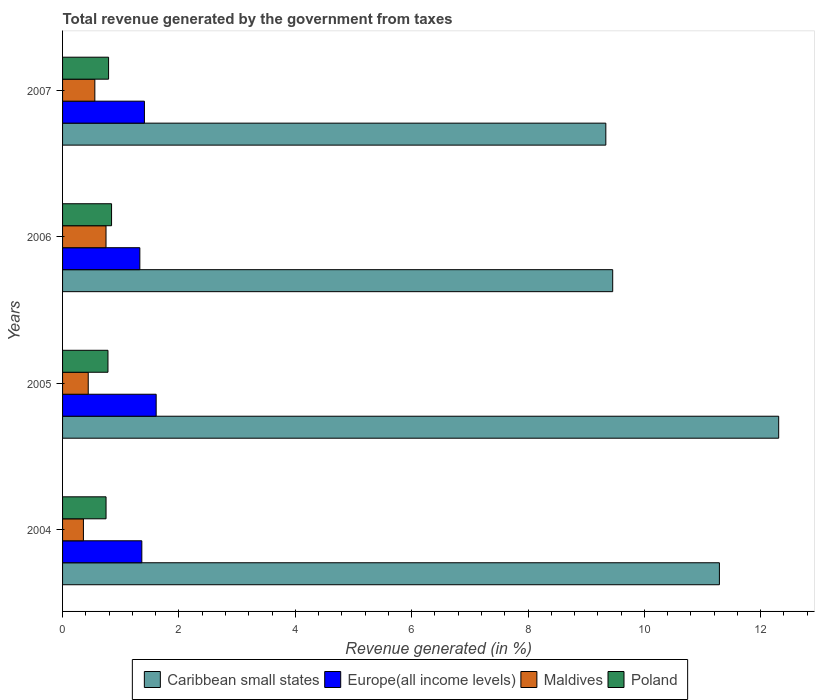How many different coloured bars are there?
Provide a short and direct response. 4. How many groups of bars are there?
Offer a very short reply. 4. Are the number of bars per tick equal to the number of legend labels?
Offer a very short reply. Yes. Are the number of bars on each tick of the Y-axis equal?
Ensure brevity in your answer.  Yes. How many bars are there on the 4th tick from the bottom?
Provide a succinct answer. 4. What is the label of the 4th group of bars from the top?
Offer a terse response. 2004. What is the total revenue generated in Europe(all income levels) in 2005?
Your response must be concise. 1.61. Across all years, what is the maximum total revenue generated in Poland?
Provide a short and direct response. 0.84. Across all years, what is the minimum total revenue generated in Maldives?
Offer a very short reply. 0.36. In which year was the total revenue generated in Maldives minimum?
Ensure brevity in your answer.  2004. What is the total total revenue generated in Maldives in the graph?
Your answer should be very brief. 2.1. What is the difference between the total revenue generated in Caribbean small states in 2004 and that in 2006?
Make the answer very short. 1.83. What is the difference between the total revenue generated in Poland in 2004 and the total revenue generated in Caribbean small states in 2006?
Make the answer very short. -8.71. What is the average total revenue generated in Maldives per year?
Make the answer very short. 0.53. In the year 2005, what is the difference between the total revenue generated in Poland and total revenue generated in Caribbean small states?
Offer a terse response. -11.53. In how many years, is the total revenue generated in Europe(all income levels) greater than 6.4 %?
Your answer should be compact. 0. What is the ratio of the total revenue generated in Poland in 2004 to that in 2007?
Provide a succinct answer. 0.94. Is the difference between the total revenue generated in Poland in 2005 and 2006 greater than the difference between the total revenue generated in Caribbean small states in 2005 and 2006?
Your answer should be very brief. No. What is the difference between the highest and the second highest total revenue generated in Poland?
Provide a short and direct response. 0.05. What is the difference between the highest and the lowest total revenue generated in Poland?
Your answer should be very brief. 0.09. In how many years, is the total revenue generated in Europe(all income levels) greater than the average total revenue generated in Europe(all income levels) taken over all years?
Your answer should be compact. 1. What does the 2nd bar from the top in 2005 represents?
Your response must be concise. Maldives. What does the 3rd bar from the bottom in 2005 represents?
Your response must be concise. Maldives. How many bars are there?
Offer a terse response. 16. How many years are there in the graph?
Offer a terse response. 4. What is the difference between two consecutive major ticks on the X-axis?
Your response must be concise. 2. Are the values on the major ticks of X-axis written in scientific E-notation?
Ensure brevity in your answer.  No. Does the graph contain any zero values?
Give a very brief answer. No. Does the graph contain grids?
Provide a succinct answer. No. Where does the legend appear in the graph?
Ensure brevity in your answer.  Bottom center. What is the title of the graph?
Your answer should be very brief. Total revenue generated by the government from taxes. Does "Morocco" appear as one of the legend labels in the graph?
Offer a terse response. No. What is the label or title of the X-axis?
Offer a very short reply. Revenue generated (in %). What is the Revenue generated (in %) of Caribbean small states in 2004?
Offer a very short reply. 11.29. What is the Revenue generated (in %) of Europe(all income levels) in 2004?
Give a very brief answer. 1.36. What is the Revenue generated (in %) in Maldives in 2004?
Your response must be concise. 0.36. What is the Revenue generated (in %) of Poland in 2004?
Your answer should be compact. 0.75. What is the Revenue generated (in %) of Caribbean small states in 2005?
Make the answer very short. 12.31. What is the Revenue generated (in %) of Europe(all income levels) in 2005?
Your response must be concise. 1.61. What is the Revenue generated (in %) of Maldives in 2005?
Your answer should be compact. 0.44. What is the Revenue generated (in %) in Poland in 2005?
Your response must be concise. 0.78. What is the Revenue generated (in %) in Caribbean small states in 2006?
Ensure brevity in your answer.  9.46. What is the Revenue generated (in %) in Europe(all income levels) in 2006?
Your response must be concise. 1.33. What is the Revenue generated (in %) of Maldives in 2006?
Provide a succinct answer. 0.75. What is the Revenue generated (in %) of Poland in 2006?
Offer a terse response. 0.84. What is the Revenue generated (in %) in Caribbean small states in 2007?
Keep it short and to the point. 9.34. What is the Revenue generated (in %) in Europe(all income levels) in 2007?
Offer a very short reply. 1.41. What is the Revenue generated (in %) in Maldives in 2007?
Your answer should be very brief. 0.55. What is the Revenue generated (in %) of Poland in 2007?
Offer a very short reply. 0.79. Across all years, what is the maximum Revenue generated (in %) in Caribbean small states?
Ensure brevity in your answer.  12.31. Across all years, what is the maximum Revenue generated (in %) of Europe(all income levels)?
Ensure brevity in your answer.  1.61. Across all years, what is the maximum Revenue generated (in %) of Maldives?
Provide a short and direct response. 0.75. Across all years, what is the maximum Revenue generated (in %) of Poland?
Provide a short and direct response. 0.84. Across all years, what is the minimum Revenue generated (in %) of Caribbean small states?
Provide a short and direct response. 9.34. Across all years, what is the minimum Revenue generated (in %) in Europe(all income levels)?
Ensure brevity in your answer.  1.33. Across all years, what is the minimum Revenue generated (in %) in Maldives?
Your response must be concise. 0.36. Across all years, what is the minimum Revenue generated (in %) of Poland?
Provide a short and direct response. 0.75. What is the total Revenue generated (in %) of Caribbean small states in the graph?
Give a very brief answer. 42.39. What is the total Revenue generated (in %) of Europe(all income levels) in the graph?
Offer a very short reply. 5.71. What is the total Revenue generated (in %) in Maldives in the graph?
Your answer should be very brief. 2.1. What is the total Revenue generated (in %) in Poland in the graph?
Provide a succinct answer. 3.16. What is the difference between the Revenue generated (in %) in Caribbean small states in 2004 and that in 2005?
Ensure brevity in your answer.  -1.02. What is the difference between the Revenue generated (in %) in Europe(all income levels) in 2004 and that in 2005?
Provide a succinct answer. -0.25. What is the difference between the Revenue generated (in %) of Maldives in 2004 and that in 2005?
Your response must be concise. -0.08. What is the difference between the Revenue generated (in %) in Poland in 2004 and that in 2005?
Offer a very short reply. -0.03. What is the difference between the Revenue generated (in %) of Caribbean small states in 2004 and that in 2006?
Offer a terse response. 1.83. What is the difference between the Revenue generated (in %) of Europe(all income levels) in 2004 and that in 2006?
Keep it short and to the point. 0.03. What is the difference between the Revenue generated (in %) of Maldives in 2004 and that in 2006?
Ensure brevity in your answer.  -0.39. What is the difference between the Revenue generated (in %) of Poland in 2004 and that in 2006?
Make the answer very short. -0.09. What is the difference between the Revenue generated (in %) in Caribbean small states in 2004 and that in 2007?
Give a very brief answer. 1.95. What is the difference between the Revenue generated (in %) in Europe(all income levels) in 2004 and that in 2007?
Offer a very short reply. -0.04. What is the difference between the Revenue generated (in %) in Maldives in 2004 and that in 2007?
Ensure brevity in your answer.  -0.2. What is the difference between the Revenue generated (in %) in Poland in 2004 and that in 2007?
Your answer should be very brief. -0.04. What is the difference between the Revenue generated (in %) of Caribbean small states in 2005 and that in 2006?
Ensure brevity in your answer.  2.85. What is the difference between the Revenue generated (in %) in Europe(all income levels) in 2005 and that in 2006?
Provide a succinct answer. 0.28. What is the difference between the Revenue generated (in %) in Maldives in 2005 and that in 2006?
Provide a short and direct response. -0.31. What is the difference between the Revenue generated (in %) in Poland in 2005 and that in 2006?
Keep it short and to the point. -0.06. What is the difference between the Revenue generated (in %) in Caribbean small states in 2005 and that in 2007?
Keep it short and to the point. 2.97. What is the difference between the Revenue generated (in %) in Europe(all income levels) in 2005 and that in 2007?
Give a very brief answer. 0.2. What is the difference between the Revenue generated (in %) in Maldives in 2005 and that in 2007?
Offer a terse response. -0.11. What is the difference between the Revenue generated (in %) of Poland in 2005 and that in 2007?
Provide a succinct answer. -0.01. What is the difference between the Revenue generated (in %) of Caribbean small states in 2006 and that in 2007?
Give a very brief answer. 0.12. What is the difference between the Revenue generated (in %) in Europe(all income levels) in 2006 and that in 2007?
Make the answer very short. -0.08. What is the difference between the Revenue generated (in %) in Maldives in 2006 and that in 2007?
Provide a short and direct response. 0.19. What is the difference between the Revenue generated (in %) in Poland in 2006 and that in 2007?
Offer a terse response. 0.05. What is the difference between the Revenue generated (in %) in Caribbean small states in 2004 and the Revenue generated (in %) in Europe(all income levels) in 2005?
Offer a terse response. 9.68. What is the difference between the Revenue generated (in %) of Caribbean small states in 2004 and the Revenue generated (in %) of Maldives in 2005?
Make the answer very short. 10.85. What is the difference between the Revenue generated (in %) of Caribbean small states in 2004 and the Revenue generated (in %) of Poland in 2005?
Keep it short and to the point. 10.51. What is the difference between the Revenue generated (in %) in Europe(all income levels) in 2004 and the Revenue generated (in %) in Maldives in 2005?
Ensure brevity in your answer.  0.92. What is the difference between the Revenue generated (in %) in Europe(all income levels) in 2004 and the Revenue generated (in %) in Poland in 2005?
Keep it short and to the point. 0.58. What is the difference between the Revenue generated (in %) of Maldives in 2004 and the Revenue generated (in %) of Poland in 2005?
Offer a terse response. -0.42. What is the difference between the Revenue generated (in %) in Caribbean small states in 2004 and the Revenue generated (in %) in Europe(all income levels) in 2006?
Your response must be concise. 9.96. What is the difference between the Revenue generated (in %) of Caribbean small states in 2004 and the Revenue generated (in %) of Maldives in 2006?
Keep it short and to the point. 10.54. What is the difference between the Revenue generated (in %) in Caribbean small states in 2004 and the Revenue generated (in %) in Poland in 2006?
Provide a short and direct response. 10.45. What is the difference between the Revenue generated (in %) in Europe(all income levels) in 2004 and the Revenue generated (in %) in Maldives in 2006?
Your answer should be very brief. 0.62. What is the difference between the Revenue generated (in %) of Europe(all income levels) in 2004 and the Revenue generated (in %) of Poland in 2006?
Your answer should be very brief. 0.52. What is the difference between the Revenue generated (in %) in Maldives in 2004 and the Revenue generated (in %) in Poland in 2006?
Ensure brevity in your answer.  -0.48. What is the difference between the Revenue generated (in %) of Caribbean small states in 2004 and the Revenue generated (in %) of Europe(all income levels) in 2007?
Offer a terse response. 9.88. What is the difference between the Revenue generated (in %) of Caribbean small states in 2004 and the Revenue generated (in %) of Maldives in 2007?
Your answer should be very brief. 10.74. What is the difference between the Revenue generated (in %) in Caribbean small states in 2004 and the Revenue generated (in %) in Poland in 2007?
Your answer should be compact. 10.5. What is the difference between the Revenue generated (in %) in Europe(all income levels) in 2004 and the Revenue generated (in %) in Maldives in 2007?
Your answer should be very brief. 0.81. What is the difference between the Revenue generated (in %) of Maldives in 2004 and the Revenue generated (in %) of Poland in 2007?
Provide a succinct answer. -0.43. What is the difference between the Revenue generated (in %) of Caribbean small states in 2005 and the Revenue generated (in %) of Europe(all income levels) in 2006?
Offer a terse response. 10.98. What is the difference between the Revenue generated (in %) of Caribbean small states in 2005 and the Revenue generated (in %) of Maldives in 2006?
Offer a terse response. 11.56. What is the difference between the Revenue generated (in %) in Caribbean small states in 2005 and the Revenue generated (in %) in Poland in 2006?
Offer a very short reply. 11.47. What is the difference between the Revenue generated (in %) of Europe(all income levels) in 2005 and the Revenue generated (in %) of Maldives in 2006?
Your answer should be compact. 0.86. What is the difference between the Revenue generated (in %) in Europe(all income levels) in 2005 and the Revenue generated (in %) in Poland in 2006?
Your response must be concise. 0.77. What is the difference between the Revenue generated (in %) in Maldives in 2005 and the Revenue generated (in %) in Poland in 2006?
Offer a terse response. -0.4. What is the difference between the Revenue generated (in %) of Caribbean small states in 2005 and the Revenue generated (in %) of Europe(all income levels) in 2007?
Keep it short and to the point. 10.9. What is the difference between the Revenue generated (in %) in Caribbean small states in 2005 and the Revenue generated (in %) in Maldives in 2007?
Provide a succinct answer. 11.75. What is the difference between the Revenue generated (in %) in Caribbean small states in 2005 and the Revenue generated (in %) in Poland in 2007?
Provide a succinct answer. 11.52. What is the difference between the Revenue generated (in %) in Europe(all income levels) in 2005 and the Revenue generated (in %) in Maldives in 2007?
Offer a very short reply. 1.05. What is the difference between the Revenue generated (in %) of Europe(all income levels) in 2005 and the Revenue generated (in %) of Poland in 2007?
Give a very brief answer. 0.82. What is the difference between the Revenue generated (in %) in Maldives in 2005 and the Revenue generated (in %) in Poland in 2007?
Offer a terse response. -0.35. What is the difference between the Revenue generated (in %) of Caribbean small states in 2006 and the Revenue generated (in %) of Europe(all income levels) in 2007?
Your answer should be very brief. 8.05. What is the difference between the Revenue generated (in %) of Caribbean small states in 2006 and the Revenue generated (in %) of Maldives in 2007?
Provide a short and direct response. 8.9. What is the difference between the Revenue generated (in %) in Caribbean small states in 2006 and the Revenue generated (in %) in Poland in 2007?
Your response must be concise. 8.66. What is the difference between the Revenue generated (in %) of Europe(all income levels) in 2006 and the Revenue generated (in %) of Maldives in 2007?
Your response must be concise. 0.77. What is the difference between the Revenue generated (in %) of Europe(all income levels) in 2006 and the Revenue generated (in %) of Poland in 2007?
Provide a succinct answer. 0.54. What is the difference between the Revenue generated (in %) in Maldives in 2006 and the Revenue generated (in %) in Poland in 2007?
Your answer should be very brief. -0.04. What is the average Revenue generated (in %) in Caribbean small states per year?
Give a very brief answer. 10.6. What is the average Revenue generated (in %) in Europe(all income levels) per year?
Offer a very short reply. 1.43. What is the average Revenue generated (in %) in Maldives per year?
Your response must be concise. 0.53. What is the average Revenue generated (in %) in Poland per year?
Provide a succinct answer. 0.79. In the year 2004, what is the difference between the Revenue generated (in %) in Caribbean small states and Revenue generated (in %) in Europe(all income levels)?
Your answer should be compact. 9.93. In the year 2004, what is the difference between the Revenue generated (in %) in Caribbean small states and Revenue generated (in %) in Maldives?
Offer a terse response. 10.93. In the year 2004, what is the difference between the Revenue generated (in %) in Caribbean small states and Revenue generated (in %) in Poland?
Keep it short and to the point. 10.54. In the year 2004, what is the difference between the Revenue generated (in %) in Europe(all income levels) and Revenue generated (in %) in Poland?
Ensure brevity in your answer.  0.61. In the year 2004, what is the difference between the Revenue generated (in %) in Maldives and Revenue generated (in %) in Poland?
Give a very brief answer. -0.39. In the year 2005, what is the difference between the Revenue generated (in %) of Caribbean small states and Revenue generated (in %) of Maldives?
Offer a very short reply. 11.87. In the year 2005, what is the difference between the Revenue generated (in %) in Caribbean small states and Revenue generated (in %) in Poland?
Offer a terse response. 11.53. In the year 2005, what is the difference between the Revenue generated (in %) in Europe(all income levels) and Revenue generated (in %) in Maldives?
Provide a succinct answer. 1.17. In the year 2005, what is the difference between the Revenue generated (in %) in Europe(all income levels) and Revenue generated (in %) in Poland?
Your response must be concise. 0.83. In the year 2005, what is the difference between the Revenue generated (in %) in Maldives and Revenue generated (in %) in Poland?
Your response must be concise. -0.34. In the year 2006, what is the difference between the Revenue generated (in %) of Caribbean small states and Revenue generated (in %) of Europe(all income levels)?
Provide a succinct answer. 8.13. In the year 2006, what is the difference between the Revenue generated (in %) of Caribbean small states and Revenue generated (in %) of Maldives?
Make the answer very short. 8.71. In the year 2006, what is the difference between the Revenue generated (in %) in Caribbean small states and Revenue generated (in %) in Poland?
Your answer should be compact. 8.61. In the year 2006, what is the difference between the Revenue generated (in %) of Europe(all income levels) and Revenue generated (in %) of Maldives?
Your response must be concise. 0.58. In the year 2006, what is the difference between the Revenue generated (in %) of Europe(all income levels) and Revenue generated (in %) of Poland?
Your answer should be very brief. 0.49. In the year 2006, what is the difference between the Revenue generated (in %) of Maldives and Revenue generated (in %) of Poland?
Ensure brevity in your answer.  -0.1. In the year 2007, what is the difference between the Revenue generated (in %) in Caribbean small states and Revenue generated (in %) in Europe(all income levels)?
Offer a terse response. 7.93. In the year 2007, what is the difference between the Revenue generated (in %) of Caribbean small states and Revenue generated (in %) of Maldives?
Ensure brevity in your answer.  8.78. In the year 2007, what is the difference between the Revenue generated (in %) in Caribbean small states and Revenue generated (in %) in Poland?
Your response must be concise. 8.55. In the year 2007, what is the difference between the Revenue generated (in %) in Europe(all income levels) and Revenue generated (in %) in Maldives?
Offer a very short reply. 0.85. In the year 2007, what is the difference between the Revenue generated (in %) in Europe(all income levels) and Revenue generated (in %) in Poland?
Keep it short and to the point. 0.62. In the year 2007, what is the difference between the Revenue generated (in %) in Maldives and Revenue generated (in %) in Poland?
Provide a succinct answer. -0.24. What is the ratio of the Revenue generated (in %) of Caribbean small states in 2004 to that in 2005?
Your response must be concise. 0.92. What is the ratio of the Revenue generated (in %) in Europe(all income levels) in 2004 to that in 2005?
Your answer should be very brief. 0.85. What is the ratio of the Revenue generated (in %) of Maldives in 2004 to that in 2005?
Your answer should be very brief. 0.81. What is the ratio of the Revenue generated (in %) of Poland in 2004 to that in 2005?
Your answer should be compact. 0.96. What is the ratio of the Revenue generated (in %) of Caribbean small states in 2004 to that in 2006?
Provide a short and direct response. 1.19. What is the ratio of the Revenue generated (in %) in Europe(all income levels) in 2004 to that in 2006?
Offer a very short reply. 1.03. What is the ratio of the Revenue generated (in %) of Maldives in 2004 to that in 2006?
Provide a short and direct response. 0.48. What is the ratio of the Revenue generated (in %) in Poland in 2004 to that in 2006?
Provide a succinct answer. 0.89. What is the ratio of the Revenue generated (in %) in Caribbean small states in 2004 to that in 2007?
Your response must be concise. 1.21. What is the ratio of the Revenue generated (in %) in Europe(all income levels) in 2004 to that in 2007?
Your answer should be very brief. 0.97. What is the ratio of the Revenue generated (in %) in Maldives in 2004 to that in 2007?
Give a very brief answer. 0.65. What is the ratio of the Revenue generated (in %) in Poland in 2004 to that in 2007?
Ensure brevity in your answer.  0.94. What is the ratio of the Revenue generated (in %) of Caribbean small states in 2005 to that in 2006?
Make the answer very short. 1.3. What is the ratio of the Revenue generated (in %) in Europe(all income levels) in 2005 to that in 2006?
Make the answer very short. 1.21. What is the ratio of the Revenue generated (in %) in Maldives in 2005 to that in 2006?
Your response must be concise. 0.59. What is the ratio of the Revenue generated (in %) in Poland in 2005 to that in 2006?
Provide a succinct answer. 0.93. What is the ratio of the Revenue generated (in %) in Caribbean small states in 2005 to that in 2007?
Give a very brief answer. 1.32. What is the ratio of the Revenue generated (in %) of Europe(all income levels) in 2005 to that in 2007?
Your answer should be compact. 1.14. What is the ratio of the Revenue generated (in %) in Maldives in 2005 to that in 2007?
Make the answer very short. 0.8. What is the ratio of the Revenue generated (in %) of Poland in 2005 to that in 2007?
Make the answer very short. 0.99. What is the ratio of the Revenue generated (in %) of Caribbean small states in 2006 to that in 2007?
Your answer should be compact. 1.01. What is the ratio of the Revenue generated (in %) of Europe(all income levels) in 2006 to that in 2007?
Provide a short and direct response. 0.94. What is the ratio of the Revenue generated (in %) in Maldives in 2006 to that in 2007?
Your answer should be compact. 1.35. What is the ratio of the Revenue generated (in %) in Poland in 2006 to that in 2007?
Offer a very short reply. 1.06. What is the difference between the highest and the second highest Revenue generated (in %) in Europe(all income levels)?
Keep it short and to the point. 0.2. What is the difference between the highest and the second highest Revenue generated (in %) of Maldives?
Your answer should be compact. 0.19. What is the difference between the highest and the second highest Revenue generated (in %) in Poland?
Provide a succinct answer. 0.05. What is the difference between the highest and the lowest Revenue generated (in %) in Caribbean small states?
Offer a very short reply. 2.97. What is the difference between the highest and the lowest Revenue generated (in %) in Europe(all income levels)?
Your answer should be very brief. 0.28. What is the difference between the highest and the lowest Revenue generated (in %) of Maldives?
Your answer should be compact. 0.39. What is the difference between the highest and the lowest Revenue generated (in %) in Poland?
Your answer should be compact. 0.09. 